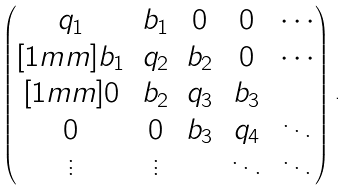<formula> <loc_0><loc_0><loc_500><loc_500>\begin{pmatrix} q _ { 1 } & b _ { 1 } & 0 & 0 & \cdots \\ [ 1 m m ] b _ { 1 } & q _ { 2 } & b _ { 2 } & 0 & \cdots \\ [ 1 m m ] 0 & b _ { 2 } & q _ { 3 } & b _ { 3 } & \\ 0 & 0 & b _ { 3 } & q _ { 4 } & \ddots \\ \vdots & \vdots & & \ddots & \ddots \end{pmatrix} \, .</formula> 